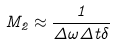<formula> <loc_0><loc_0><loc_500><loc_500>M _ { 2 } \approx \frac { 1 } { \Delta \omega \Delta t \delta }</formula> 